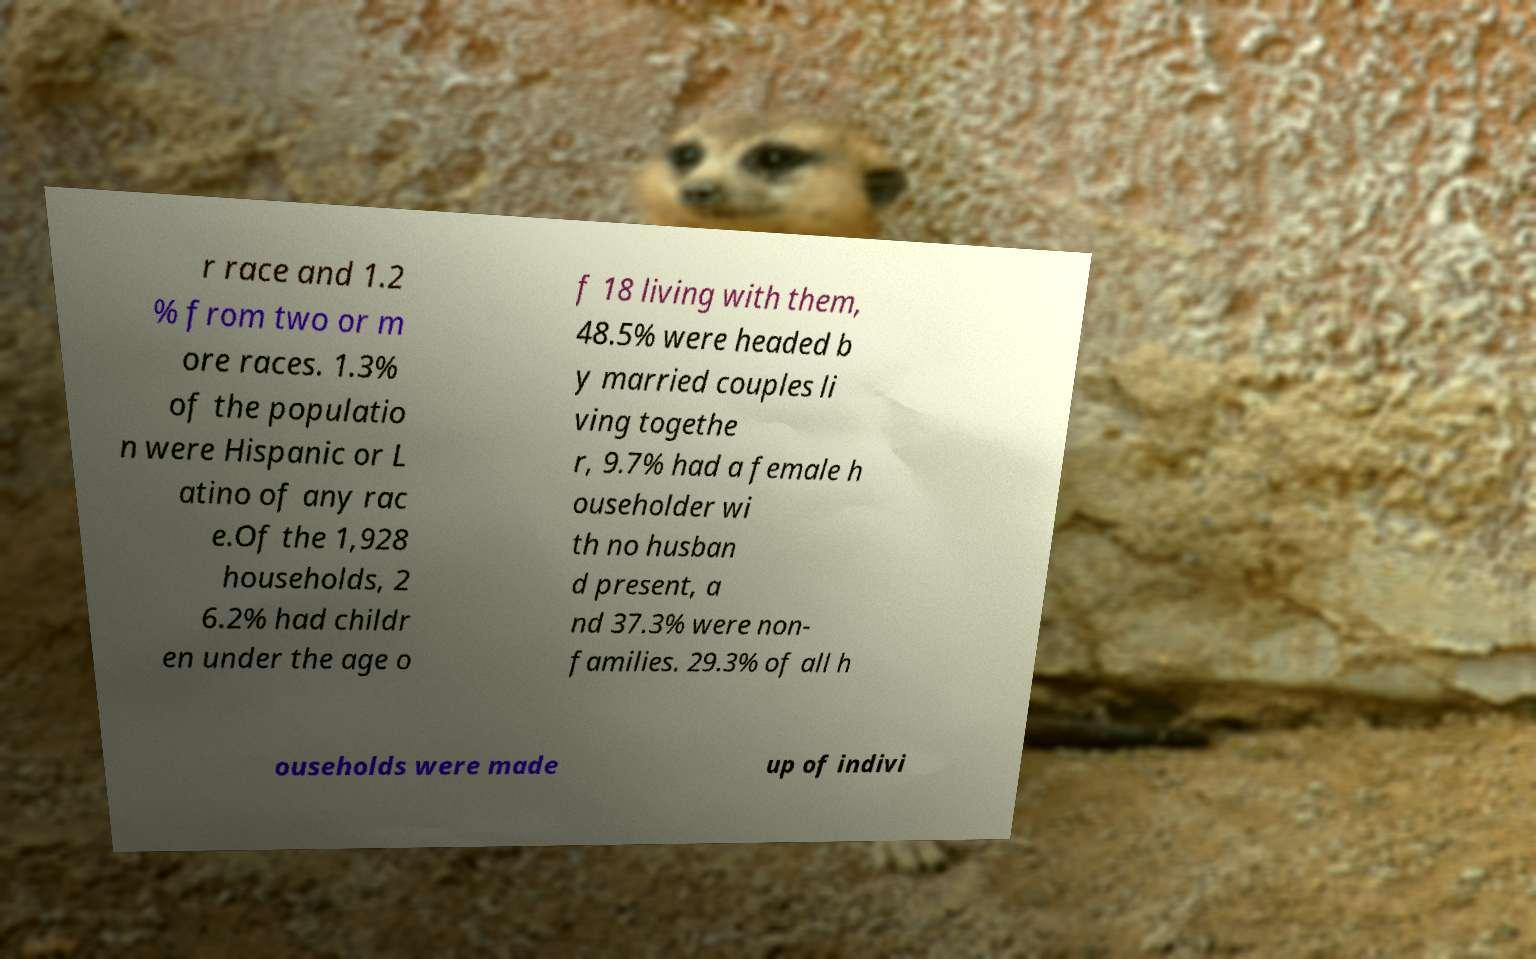Please identify and transcribe the text found in this image. r race and 1.2 % from two or m ore races. 1.3% of the populatio n were Hispanic or L atino of any rac e.Of the 1,928 households, 2 6.2% had childr en under the age o f 18 living with them, 48.5% were headed b y married couples li ving togethe r, 9.7% had a female h ouseholder wi th no husban d present, a nd 37.3% were non- families. 29.3% of all h ouseholds were made up of indivi 